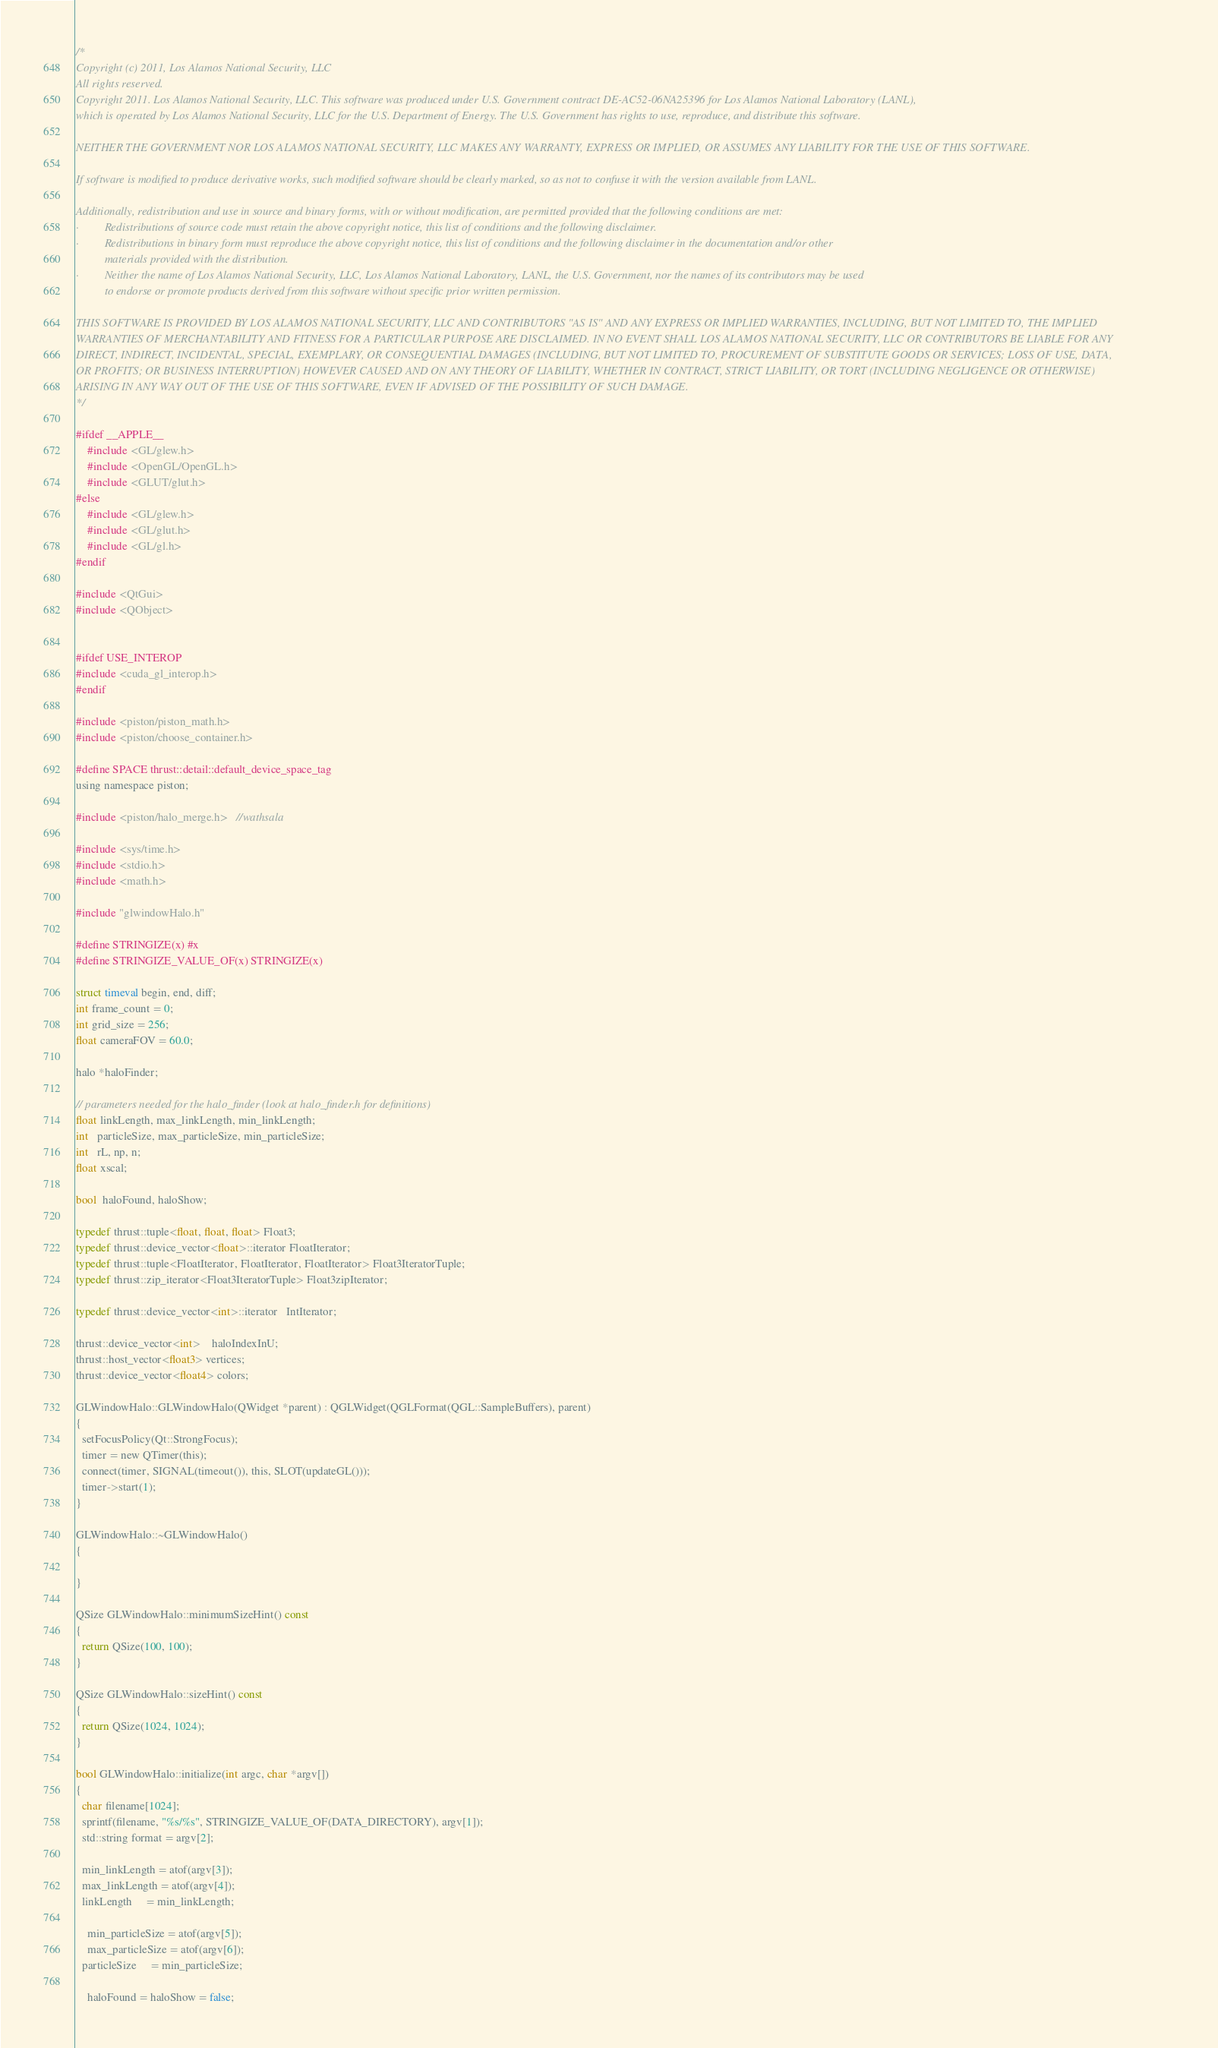<code> <loc_0><loc_0><loc_500><loc_500><_Cuda_>/*
Copyright (c) 2011, Los Alamos National Security, LLC
All rights reserved.
Copyright 2011. Los Alamos National Security, LLC. This software was produced under U.S. Government contract DE-AC52-06NA25396 for Los Alamos National Laboratory (LANL),
which is operated by Los Alamos National Security, LLC for the U.S. Department of Energy. The U.S. Government has rights to use, reproduce, and distribute this software.

NEITHER THE GOVERNMENT NOR LOS ALAMOS NATIONAL SECURITY, LLC MAKES ANY WARRANTY, EXPRESS OR IMPLIED, OR ASSUMES ANY LIABILITY FOR THE USE OF THIS SOFTWARE.

If software is modified to produce derivative works, such modified software should be clearly marked, so as not to confuse it with the version available from LANL.

Additionally, redistribution and use in source and binary forms, with or without modification, are permitted provided that the following conditions are met:
·         Redistributions of source code must retain the above copyright notice, this list of conditions and the following disclaimer.
·         Redistributions in binary form must reproduce the above copyright notice, this list of conditions and the following disclaimer in the documentation and/or other
          materials provided with the distribution.
·         Neither the name of Los Alamos National Security, LLC, Los Alamos National Laboratory, LANL, the U.S. Government, nor the names of its contributors may be used
          to endorse or promote products derived from this software without specific prior written permission.

THIS SOFTWARE IS PROVIDED BY LOS ALAMOS NATIONAL SECURITY, LLC AND CONTRIBUTORS "AS IS" AND ANY EXPRESS OR IMPLIED WARRANTIES, INCLUDING, BUT NOT LIMITED TO, THE IMPLIED
WARRANTIES OF MERCHANTABILITY AND FITNESS FOR A PARTICULAR PURPOSE ARE DISCLAIMED. IN NO EVENT SHALL LOS ALAMOS NATIONAL SECURITY, LLC OR CONTRIBUTORS BE LIABLE FOR ANY
DIRECT, INDIRECT, INCIDENTAL, SPECIAL, EXEMPLARY, OR CONSEQUENTIAL DAMAGES (INCLUDING, BUT NOT LIMITED TO, PROCUREMENT OF SUBSTITUTE GOODS OR SERVICES; LOSS OF USE, DATA,
OR PROFITS; OR BUSINESS INTERRUPTION) HOWEVER CAUSED AND ON ANY THEORY OF LIABILITY, WHETHER IN CONTRACT, STRICT LIABILITY, OR TORT (INCLUDING NEGLIGENCE OR OTHERWISE)
ARISING IN ANY WAY OUT OF THE USE OF THIS SOFTWARE, EVEN IF ADVISED OF THE POSSIBILITY OF SUCH DAMAGE.
*/

#ifdef __APPLE__
    #include <GL/glew.h>
    #include <OpenGL/OpenGL.h>
    #include <GLUT/glut.h>
#else
    #include <GL/glew.h>
    #include <GL/glut.h>
    #include <GL/gl.h>
#endif

#include <QtGui>
#include <QObject>


#ifdef USE_INTEROP
#include <cuda_gl_interop.h>
#endif

#include <piston/piston_math.h> 
#include <piston/choose_container.h>

#define SPACE thrust::detail::default_device_space_tag
using namespace piston;

#include <piston/halo_merge.h>   //wathsala

#include <sys/time.h>
#include <stdio.h>
#include <math.h>

#include "glwindowHalo.h"

#define STRINGIZE(x) #x
#define STRINGIZE_VALUE_OF(x) STRINGIZE(x)

struct timeval begin, end, diff;
int frame_count = 0;
int grid_size = 256;
float cameraFOV = 60.0;

halo *haloFinder;

// parameters needed for the halo_finder (look at halo_finder.h for definitions)
float linkLength, max_linkLength, min_linkLength;
int   particleSize, max_particleSize, min_particleSize;
int   rL, np, n;
float xscal;

bool  haloFound, haloShow;

typedef thrust::tuple<float, float, float> Float3;
typedef thrust::device_vector<float>::iterator FloatIterator;
typedef thrust::tuple<FloatIterator, FloatIterator, FloatIterator> Float3IteratorTuple;
typedef thrust::zip_iterator<Float3IteratorTuple> Float3zipIterator;

typedef thrust::device_vector<int>::iterator   IntIterator;

thrust::device_vector<int>    haloIndexInU;
thrust::host_vector<float3> vertices;
thrust::device_vector<float4> colors;

GLWindowHalo::GLWindowHalo(QWidget *parent) : QGLWidget(QGLFormat(QGL::SampleBuffers), parent)
{
  setFocusPolicy(Qt::StrongFocus);
  timer = new QTimer(this);
  connect(timer, SIGNAL(timeout()), this, SLOT(updateGL()));
  timer->start(1);
}

GLWindowHalo::~GLWindowHalo()
{

}

QSize GLWindowHalo::minimumSizeHint() const
{
  return QSize(100, 100);
}

QSize GLWindowHalo::sizeHint() const
{
  return QSize(1024, 1024);
}

bool GLWindowHalo::initialize(int argc, char *argv[])
{
  char filename[1024];
  sprintf(filename, "%s/%s", STRINGIZE_VALUE_OF(DATA_DIRECTORY), argv[1]);
  std::string format = argv[2];

  min_linkLength = atof(argv[3]);
  max_linkLength = atof(argv[4]);
  linkLength     = min_linkLength;
	
	min_particleSize = atof(argv[5]);
	max_particleSize = atof(argv[6]);
  particleSize     = min_particleSize;	

	haloFound = haloShow = false;
</code> 